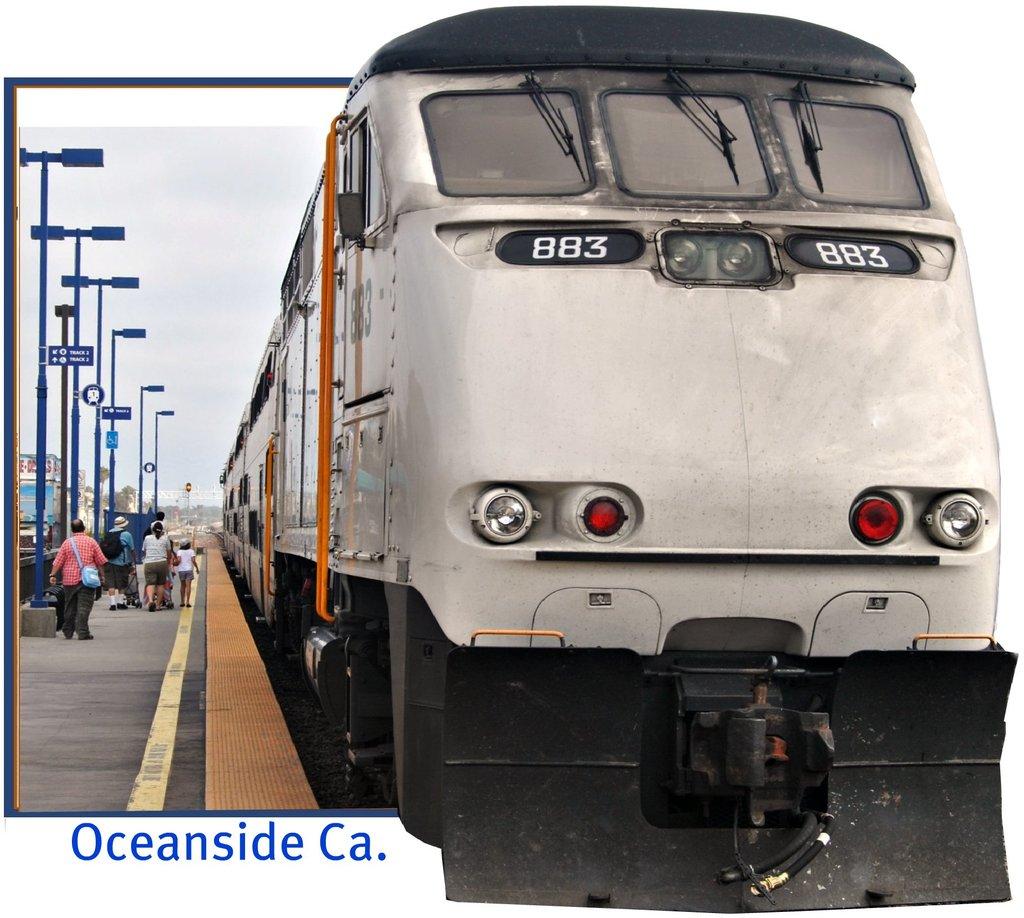Where is this train located?
Provide a succinct answer. Oceanside california. What number is the train?
Keep it short and to the point. 883. 